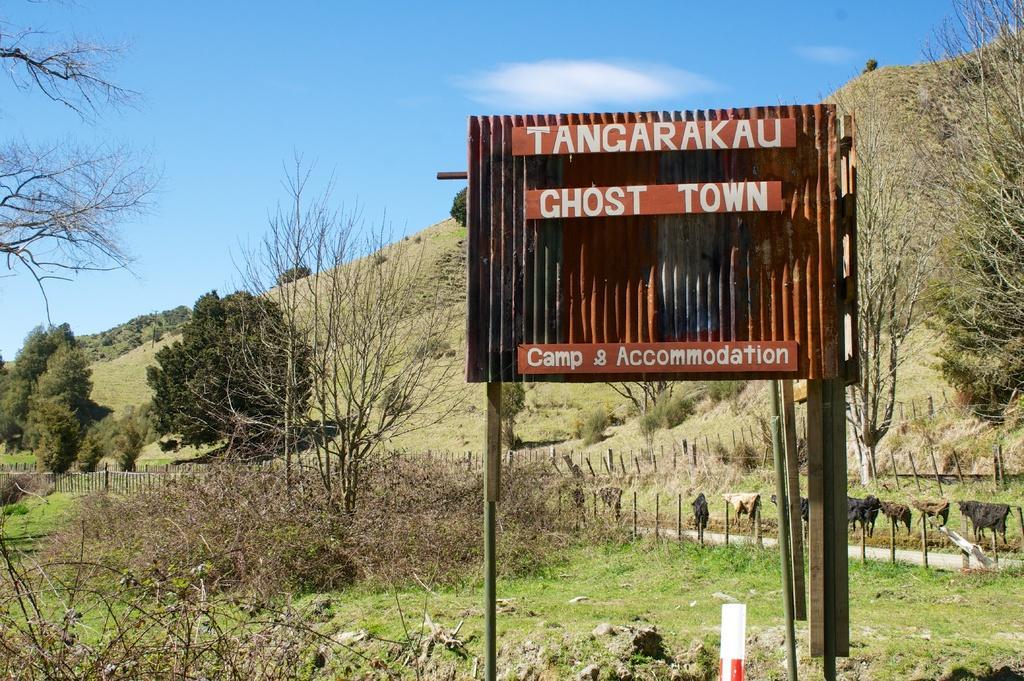Please provide a concise description of this image. In the picture I can see the name sign indication board pole on the right side. There are trees on the left side and the right side as well. I can see the plants and green grass at the bottom of the picture. I can see the rock poles in the picture. There are clouds in the sky. 